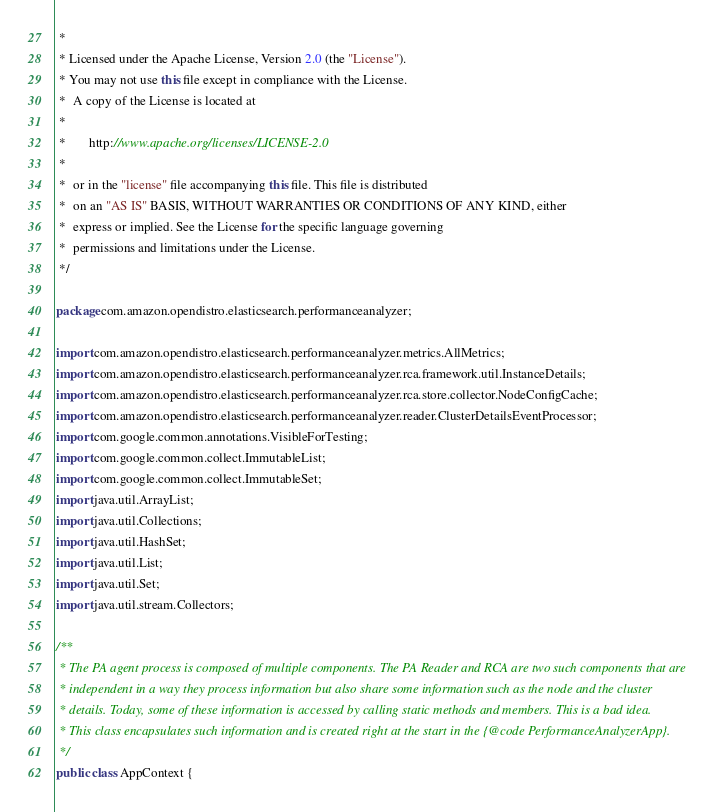<code> <loc_0><loc_0><loc_500><loc_500><_Java_> *
 * Licensed under the Apache License, Version 2.0 (the "License").
 * You may not use this file except in compliance with the License.
 *  A copy of the License is located at
 *
 *       http://www.apache.org/licenses/LICENSE-2.0
 *
 *  or in the "license" file accompanying this file. This file is distributed
 *  on an "AS IS" BASIS, WITHOUT WARRANTIES OR CONDITIONS OF ANY KIND, either
 *  express or implied. See the License for the specific language governing
 *  permissions and limitations under the License.
 */

package com.amazon.opendistro.elasticsearch.performanceanalyzer;

import com.amazon.opendistro.elasticsearch.performanceanalyzer.metrics.AllMetrics;
import com.amazon.opendistro.elasticsearch.performanceanalyzer.rca.framework.util.InstanceDetails;
import com.amazon.opendistro.elasticsearch.performanceanalyzer.rca.store.collector.NodeConfigCache;
import com.amazon.opendistro.elasticsearch.performanceanalyzer.reader.ClusterDetailsEventProcessor;
import com.google.common.annotations.VisibleForTesting;
import com.google.common.collect.ImmutableList;
import com.google.common.collect.ImmutableSet;
import java.util.ArrayList;
import java.util.Collections;
import java.util.HashSet;
import java.util.List;
import java.util.Set;
import java.util.stream.Collectors;

/**
 * The PA agent process is composed of multiple components. The PA Reader and RCA are two such components that are
 * independent in a way they process information but also share some information such as the node and the cluster
 * details. Today, some of these information is accessed by calling static methods and members. This is a bad idea.
 * This class encapsulates such information and is created right at the start in the {@code PerformanceAnalyzerApp}.
 */
public class AppContext {</code> 